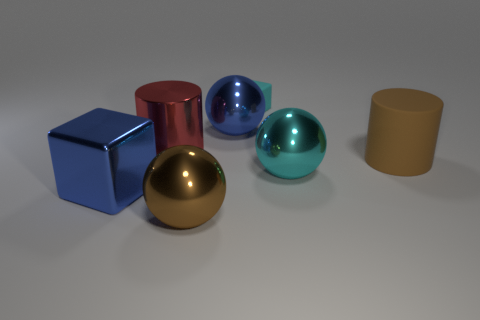What number of big metallic objects are right of the metallic cube and left of the cyan rubber block?
Provide a succinct answer. 3. What number of objects are the same material as the big cyan sphere?
Ensure brevity in your answer.  4. What is the size of the blue thing that is in front of the big sphere right of the tiny block?
Make the answer very short. Large. Is there a big matte thing of the same shape as the brown shiny thing?
Keep it short and to the point. No. There is a cyan object behind the big red object; is its size the same as the cylinder that is right of the matte cube?
Keep it short and to the point. No. Are there fewer metal cylinders that are behind the metallic cylinder than tiny cyan matte blocks that are to the left of the big brown metallic sphere?
Your answer should be very brief. No. There is a sphere that is the same color as the small thing; what is its material?
Offer a terse response. Metal. What is the color of the big shiny ball in front of the metallic cube?
Provide a short and direct response. Brown. Do the metal cylinder and the small matte thing have the same color?
Your answer should be very brief. No. There is a blue thing to the right of the big object in front of the shiny cube; how many cylinders are on the right side of it?
Offer a very short reply. 1. 